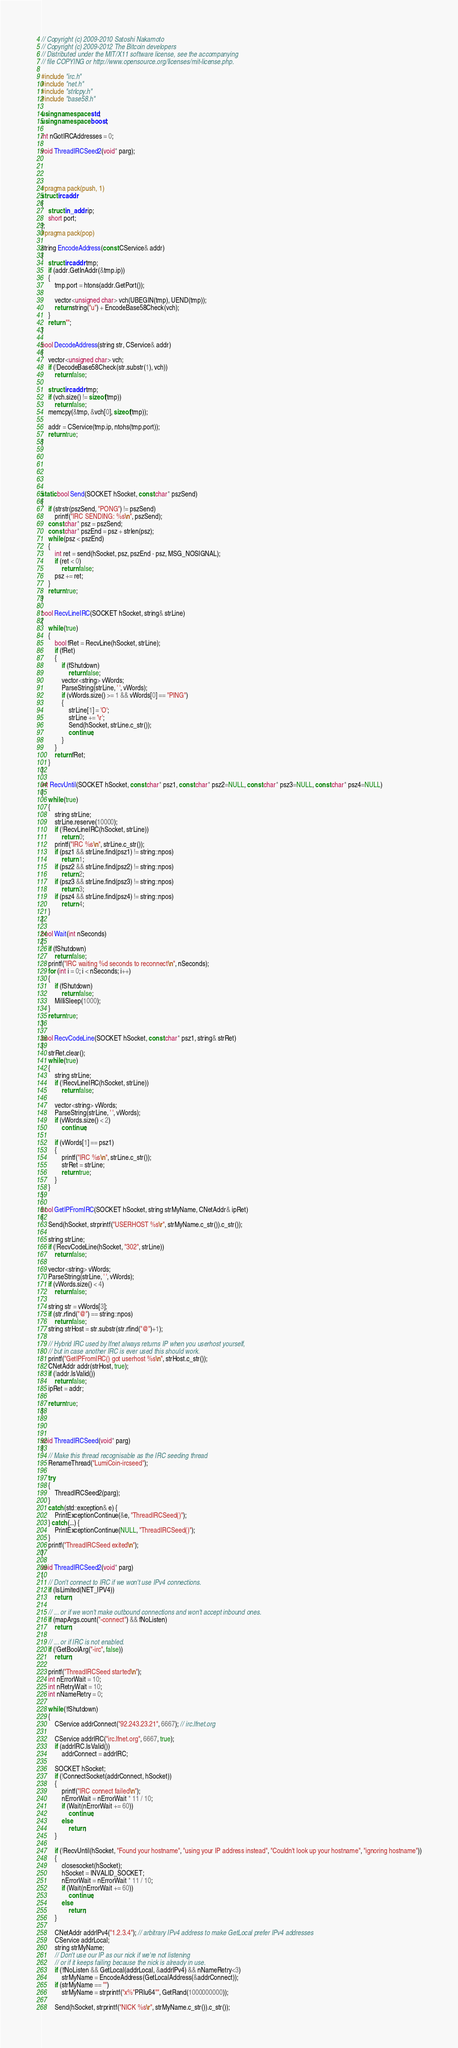<code> <loc_0><loc_0><loc_500><loc_500><_C++_>// Copyright (c) 2009-2010 Satoshi Nakamoto
// Copyright (c) 2009-2012 The Bitcoin developers
// Distributed under the MIT/X11 software license, see the accompanying
// file COPYING or http://www.opensource.org/licenses/mit-license.php.

#include "irc.h"
#include "net.h"
#include "strlcpy.h"
#include "base58.h"

using namespace std;
using namespace boost;

int nGotIRCAddresses = 0;

void ThreadIRCSeed2(void* parg);




#pragma pack(push, 1)
struct ircaddr
{
    struct in_addr ip;
    short port;
};
#pragma pack(pop)

string EncodeAddress(const CService& addr)
{
    struct ircaddr tmp;
    if (addr.GetInAddr(&tmp.ip))
    {
        tmp.port = htons(addr.GetPort());

        vector<unsigned char> vch(UBEGIN(tmp), UEND(tmp));
        return string("u") + EncodeBase58Check(vch);
    }
    return "";
}

bool DecodeAddress(string str, CService& addr)
{
    vector<unsigned char> vch;
    if (!DecodeBase58Check(str.substr(1), vch))
        return false;

    struct ircaddr tmp;
    if (vch.size() != sizeof(tmp))
        return false;
    memcpy(&tmp, &vch[0], sizeof(tmp));

    addr = CService(tmp.ip, ntohs(tmp.port));
    return true;
}






static bool Send(SOCKET hSocket, const char* pszSend)
{
    if (strstr(pszSend, "PONG") != pszSend)
        printf("IRC SENDING: %s\n", pszSend);
    const char* psz = pszSend;
    const char* pszEnd = psz + strlen(psz);
    while (psz < pszEnd)
    {
        int ret = send(hSocket, psz, pszEnd - psz, MSG_NOSIGNAL);
        if (ret < 0)
            return false;
        psz += ret;
    }
    return true;
}

bool RecvLineIRC(SOCKET hSocket, string& strLine)
{
    while (true)
    {
        bool fRet = RecvLine(hSocket, strLine);
        if (fRet)
        {
            if (fShutdown)
                return false;
            vector<string> vWords;
            ParseString(strLine, ' ', vWords);
            if (vWords.size() >= 1 && vWords[0] == "PING")
            {
                strLine[1] = 'O';
                strLine += '\r';
                Send(hSocket, strLine.c_str());
                continue;
            }
        }
        return fRet;
    }
}

int RecvUntil(SOCKET hSocket, const char* psz1, const char* psz2=NULL, const char* psz3=NULL, const char* psz4=NULL)
{
    while (true)
    {
        string strLine;
        strLine.reserve(10000);
        if (!RecvLineIRC(hSocket, strLine))
            return 0;
        printf("IRC %s\n", strLine.c_str());
        if (psz1 && strLine.find(psz1) != string::npos)
            return 1;
        if (psz2 && strLine.find(psz2) != string::npos)
            return 2;
        if (psz3 && strLine.find(psz3) != string::npos)
            return 3;
        if (psz4 && strLine.find(psz4) != string::npos)
            return 4;
    }
}

bool Wait(int nSeconds)
{
    if (fShutdown)
        return false;
    printf("IRC waiting %d seconds to reconnect\n", nSeconds);
    for (int i = 0; i < nSeconds; i++)
    {
        if (fShutdown)
            return false;
        MilliSleep(1000);
    }
    return true;
}

bool RecvCodeLine(SOCKET hSocket, const char* psz1, string& strRet)
{
    strRet.clear();
    while (true)
    {
        string strLine;
        if (!RecvLineIRC(hSocket, strLine))
            return false;

        vector<string> vWords;
        ParseString(strLine, ' ', vWords);
        if (vWords.size() < 2)
            continue;

        if (vWords[1] == psz1)
        {
            printf("IRC %s\n", strLine.c_str());
            strRet = strLine;
            return true;
        }
    }
}

bool GetIPFromIRC(SOCKET hSocket, string strMyName, CNetAddr& ipRet)
{
    Send(hSocket, strprintf("USERHOST %s\r", strMyName.c_str()).c_str());

    string strLine;
    if (!RecvCodeLine(hSocket, "302", strLine))
        return false;

    vector<string> vWords;
    ParseString(strLine, ' ', vWords);
    if (vWords.size() < 4)
        return false;

    string str = vWords[3];
    if (str.rfind("@") == string::npos)
        return false;
    string strHost = str.substr(str.rfind("@")+1);

    // Hybrid IRC used by lfnet always returns IP when you userhost yourself,
    // but in case another IRC is ever used this should work.
    printf("GetIPFromIRC() got userhost %s\n", strHost.c_str());
    CNetAddr addr(strHost, true);
    if (!addr.IsValid())
        return false;
    ipRet = addr;

    return true;
}



void ThreadIRCSeed(void* parg)
{
    // Make this thread recognisable as the IRC seeding thread
    RenameThread("LumiCoin-ircseed");

    try
    {
        ThreadIRCSeed2(parg);
    }
    catch (std::exception& e) {
        PrintExceptionContinue(&e, "ThreadIRCSeed()");
    } catch (...) {
        PrintExceptionContinue(NULL, "ThreadIRCSeed()");
    }
    printf("ThreadIRCSeed exited\n");
}

void ThreadIRCSeed2(void* parg)
{
    // Don't connect to IRC if we won't use IPv4 connections.
    if (IsLimited(NET_IPV4))
        return;

    // ... or if we won't make outbound connections and won't accept inbound ones.
    if (mapArgs.count("-connect") && fNoListen)
        return;

    // ... or if IRC is not enabled.
    if (!GetBoolArg("-irc", false))
        return;

    printf("ThreadIRCSeed started\n");
    int nErrorWait = 10;
    int nRetryWait = 10;
    int nNameRetry = 0;

    while (!fShutdown)
    {
        CService addrConnect("92.243.23.21", 6667); // irc.lfnet.org

        CService addrIRC("irc.lfnet.org", 6667, true);
        if (addrIRC.IsValid())
            addrConnect = addrIRC;

        SOCKET hSocket;
        if (!ConnectSocket(addrConnect, hSocket))
        {
            printf("IRC connect failed\n");
            nErrorWait = nErrorWait * 11 / 10;
            if (Wait(nErrorWait += 60))
                continue;
            else
                return;
        }

        if (!RecvUntil(hSocket, "Found your hostname", "using your IP address instead", "Couldn't look up your hostname", "ignoring hostname"))
        {
            closesocket(hSocket);
            hSocket = INVALID_SOCKET;
            nErrorWait = nErrorWait * 11 / 10;
            if (Wait(nErrorWait += 60))
                continue;
            else
                return;
        }

        CNetAddr addrIPv4("1.2.3.4"); // arbitrary IPv4 address to make GetLocal prefer IPv4 addresses
        CService addrLocal;
        string strMyName;
        // Don't use our IP as our nick if we're not listening
        // or if it keeps failing because the nick is already in use.
        if (!fNoListen && GetLocal(addrLocal, &addrIPv4) && nNameRetry<3)
            strMyName = EncodeAddress(GetLocalAddress(&addrConnect));
        if (strMyName == "")
            strMyName = strprintf("x%"PRIu64"", GetRand(1000000000));

        Send(hSocket, strprintf("NICK %s\r", strMyName.c_str()).c_str());</code> 